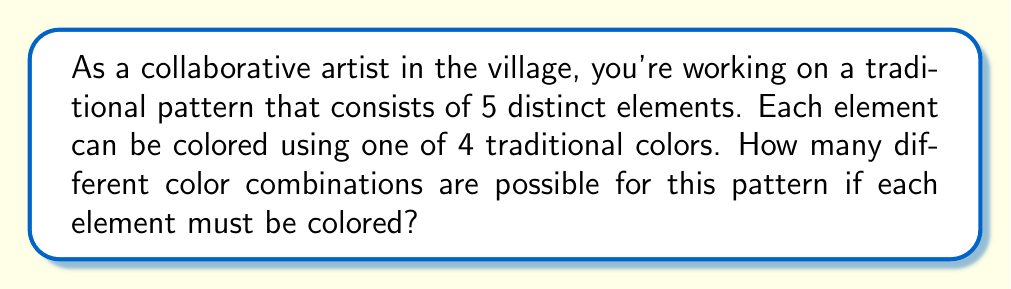Show me your answer to this math problem. Let's approach this step-by-step:

1) We have 5 distinct elements in the pattern, and each element needs to be colored.

2) For each element, we have 4 color choices.

3) This scenario follows the multiplication principle of counting. When we have a series of independent choices, we multiply the number of options for each choice.

4) In this case, we're making 5 independent color choices (one for each element), and each choice has 4 options.

5) Therefore, the total number of possible color combinations is:

   $$4 \times 4 \times 4 \times 4 \times 4 = 4^5$$

6) We can calculate this:

   $$4^5 = 4 \times 4 \times 4 \times 4 \times 4 = 1024$$

Thus, there are 1024 possible color combinations for this traditional pattern.
Answer: 1024 